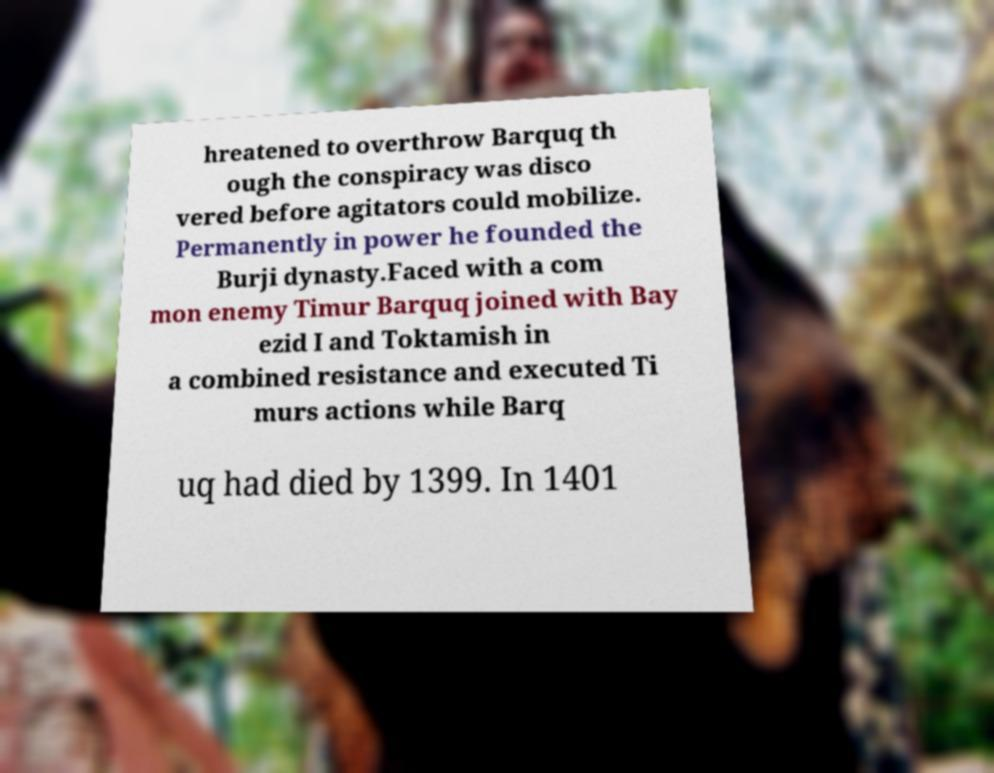Please read and relay the text visible in this image. What does it say? hreatened to overthrow Barquq th ough the conspiracy was disco vered before agitators could mobilize. Permanently in power he founded the Burji dynasty.Faced with a com mon enemy Timur Barquq joined with Bay ezid I and Toktamish in a combined resistance and executed Ti murs actions while Barq uq had died by 1399. In 1401 